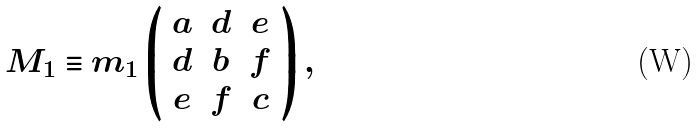Convert formula to latex. <formula><loc_0><loc_0><loc_500><loc_500>M _ { 1 } \equiv m _ { 1 } \left ( \begin{array} { c c c } a & d & e \\ d & b & f \\ e & f & c \end{array} \right ) ,</formula> 